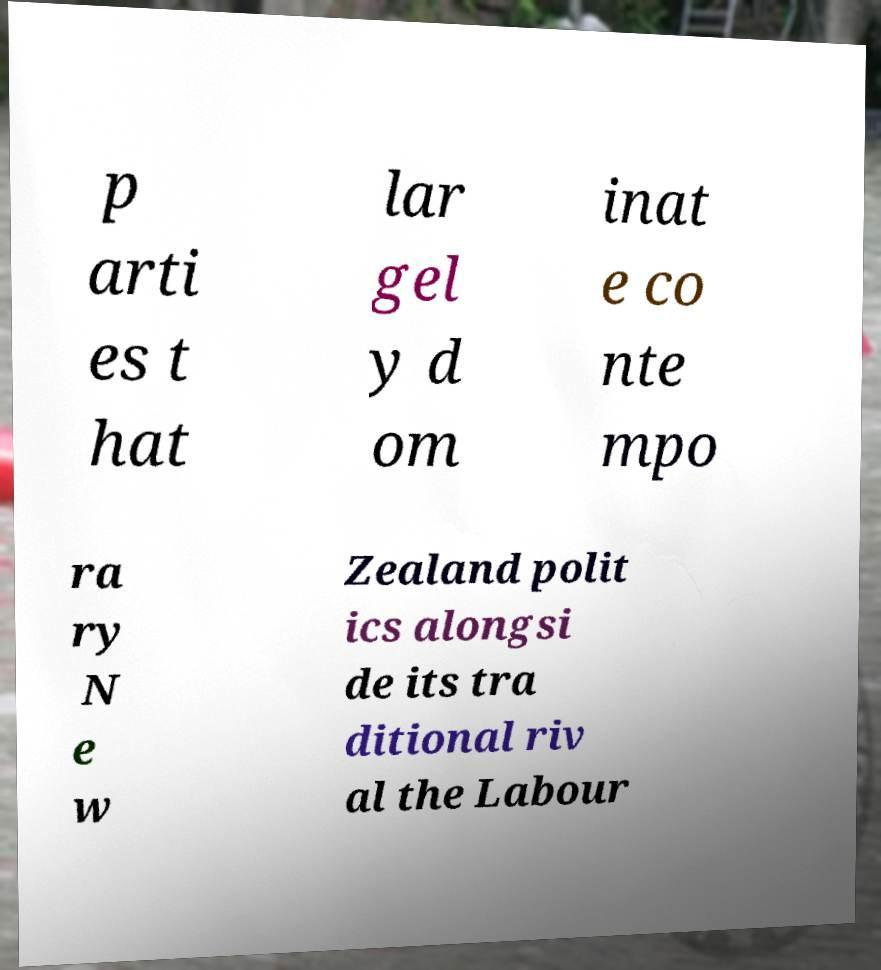Please identify and transcribe the text found in this image. p arti es t hat lar gel y d om inat e co nte mpo ra ry N e w Zealand polit ics alongsi de its tra ditional riv al the Labour 